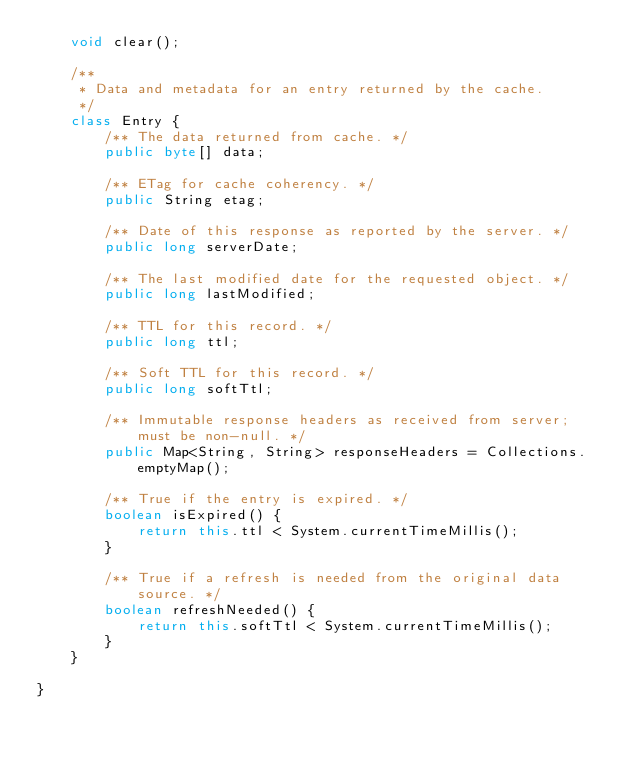<code> <loc_0><loc_0><loc_500><loc_500><_Java_>    void clear();

    /**
     * Data and metadata for an entry returned by the cache.
     */
    class Entry {
        /** The data returned from cache. */
        public byte[] data;

        /** ETag for cache coherency. */
        public String etag;

        /** Date of this response as reported by the server. */
        public long serverDate;

        /** The last modified date for the requested object. */
        public long lastModified;

        /** TTL for this record. */
        public long ttl;

        /** Soft TTL for this record. */
        public long softTtl;

        /** Immutable response headers as received from server; must be non-null. */
        public Map<String, String> responseHeaders = Collections.emptyMap();

        /** True if the entry is expired. */
        boolean isExpired() {
            return this.ttl < System.currentTimeMillis();
        }

        /** True if a refresh is needed from the original data source. */
        boolean refreshNeeded() {
            return this.softTtl < System.currentTimeMillis();
        }
    }

}
</code> 